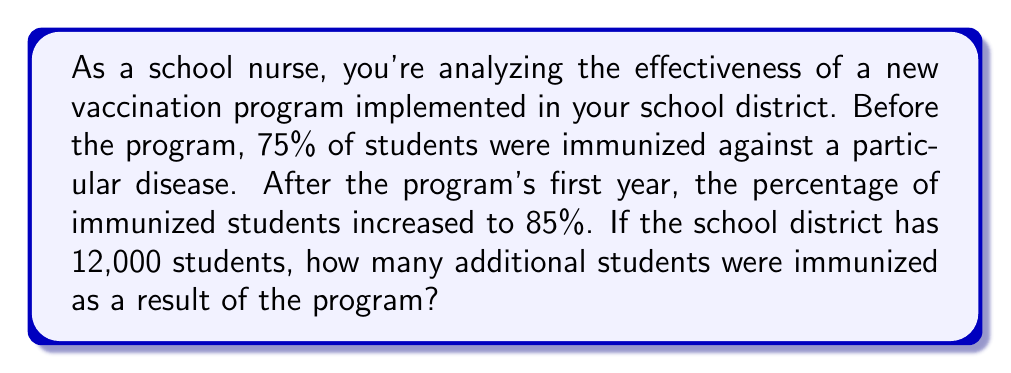What is the answer to this math problem? To solve this problem, we need to follow these steps:

1. Calculate the number of immunized students before the program:
   $75\% \text{ of } 12,000 = 0.75 \times 12,000 = 9,000$ students

2. Calculate the number of immunized students after the program:
   $85\% \text{ of } 12,000 = 0.85 \times 12,000 = 10,200$ students

3. Find the difference between the two numbers:
   $10,200 - 9,000 = 1,200$ students

Let's break it down mathematically:

$$\begin{align}
\text{Initial immunized students} &= 0.75 \times 12,000 = 9,000 \\
\text{Final immunized students} &= 0.85 \times 12,000 = 10,200 \\
\text{Difference} &= 10,200 - 9,000 = 1,200
\end{align}$$

This difference represents the additional number of students immunized as a result of the vaccination program.
Answer: 1,200 additional students were immunized as a result of the vaccination program. 